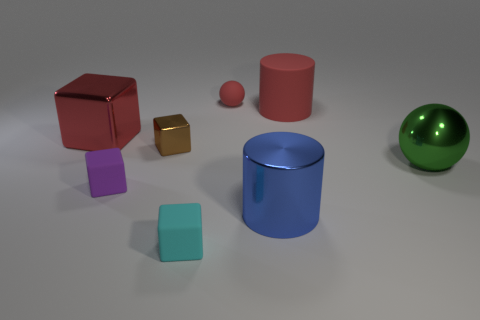Are there any big metallic objects that have the same shape as the large matte object?
Your answer should be very brief. Yes. There is a large thing that is the same color as the big metallic block; what is it made of?
Make the answer very short. Rubber. What number of rubber objects are either green spheres or small red balls?
Your answer should be compact. 1. What is the shape of the tiny red rubber thing?
Your response must be concise. Sphere. How many brown things have the same material as the blue cylinder?
Your response must be concise. 1. There is a large cylinder that is the same material as the big sphere; what color is it?
Your answer should be compact. Blue. Is the size of the rubber object that is to the left of the cyan rubber cube the same as the green metal thing?
Provide a succinct answer. No. What color is the big matte object that is the same shape as the large blue shiny thing?
Your response must be concise. Red. What shape is the tiny matte object to the right of the rubber thing that is in front of the big cylinder on the left side of the large rubber object?
Your answer should be very brief. Sphere. Is the red metallic thing the same shape as the big green metal thing?
Make the answer very short. No. 